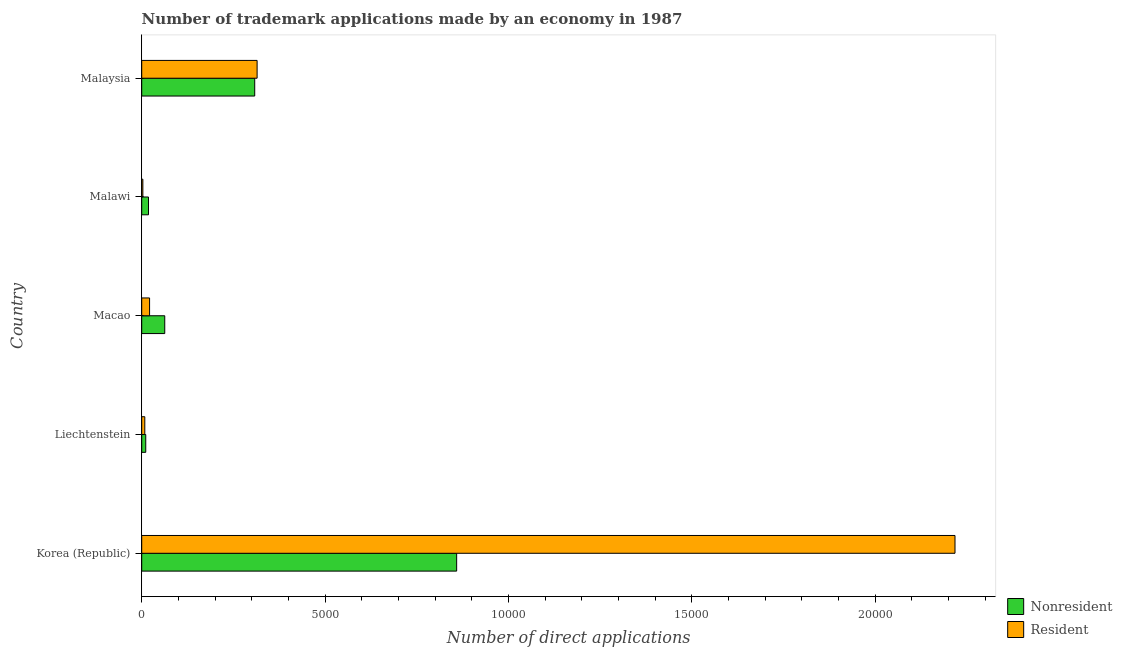How many different coloured bars are there?
Your answer should be compact. 2. How many groups of bars are there?
Your answer should be very brief. 5. Are the number of bars per tick equal to the number of legend labels?
Your answer should be very brief. Yes. Are the number of bars on each tick of the Y-axis equal?
Provide a short and direct response. Yes. What is the label of the 3rd group of bars from the top?
Keep it short and to the point. Macao. What is the number of trademark applications made by non residents in Liechtenstein?
Give a very brief answer. 110. Across all countries, what is the maximum number of trademark applications made by residents?
Provide a succinct answer. 2.22e+04. Across all countries, what is the minimum number of trademark applications made by non residents?
Your answer should be very brief. 110. In which country was the number of trademark applications made by non residents minimum?
Provide a succinct answer. Liechtenstein. What is the total number of trademark applications made by non residents in the graph?
Keep it short and to the point. 1.26e+04. What is the difference between the number of trademark applications made by non residents in Korea (Republic) and that in Liechtenstein?
Make the answer very short. 8477. What is the difference between the number of trademark applications made by non residents in Korea (Republic) and the number of trademark applications made by residents in Macao?
Your response must be concise. 8373. What is the average number of trademark applications made by residents per country?
Make the answer very short. 5130. What is the difference between the number of trademark applications made by non residents and number of trademark applications made by residents in Liechtenstein?
Your answer should be very brief. 26. In how many countries, is the number of trademark applications made by non residents greater than 21000 ?
Your answer should be very brief. 0. What is the ratio of the number of trademark applications made by residents in Korea (Republic) to that in Malaysia?
Ensure brevity in your answer.  7.05. Is the number of trademark applications made by non residents in Korea (Republic) less than that in Malawi?
Your response must be concise. No. What is the difference between the highest and the second highest number of trademark applications made by non residents?
Your answer should be compact. 5506. What is the difference between the highest and the lowest number of trademark applications made by residents?
Offer a very short reply. 2.21e+04. In how many countries, is the number of trademark applications made by residents greater than the average number of trademark applications made by residents taken over all countries?
Provide a short and direct response. 1. What does the 1st bar from the top in Malawi represents?
Offer a very short reply. Resident. What does the 2nd bar from the bottom in Macao represents?
Provide a succinct answer. Resident. Are all the bars in the graph horizontal?
Provide a short and direct response. Yes. What is the difference between two consecutive major ticks on the X-axis?
Provide a succinct answer. 5000. Are the values on the major ticks of X-axis written in scientific E-notation?
Ensure brevity in your answer.  No. Does the graph contain any zero values?
Your answer should be compact. No. How many legend labels are there?
Your response must be concise. 2. How are the legend labels stacked?
Make the answer very short. Vertical. What is the title of the graph?
Offer a terse response. Number of trademark applications made by an economy in 1987. Does "Drinking water services" appear as one of the legend labels in the graph?
Ensure brevity in your answer.  No. What is the label or title of the X-axis?
Your answer should be compact. Number of direct applications. What is the label or title of the Y-axis?
Offer a terse response. Country. What is the Number of direct applications in Nonresident in Korea (Republic)?
Offer a very short reply. 8587. What is the Number of direct applications in Resident in Korea (Republic)?
Keep it short and to the point. 2.22e+04. What is the Number of direct applications in Nonresident in Liechtenstein?
Your answer should be compact. 110. What is the Number of direct applications in Resident in Liechtenstein?
Your answer should be compact. 84. What is the Number of direct applications of Nonresident in Macao?
Offer a terse response. 628. What is the Number of direct applications of Resident in Macao?
Provide a succinct answer. 214. What is the Number of direct applications of Nonresident in Malawi?
Offer a very short reply. 185. What is the Number of direct applications of Resident in Malawi?
Your answer should be compact. 31. What is the Number of direct applications in Nonresident in Malaysia?
Your answer should be compact. 3081. What is the Number of direct applications of Resident in Malaysia?
Give a very brief answer. 3146. Across all countries, what is the maximum Number of direct applications of Nonresident?
Keep it short and to the point. 8587. Across all countries, what is the maximum Number of direct applications of Resident?
Provide a succinct answer. 2.22e+04. Across all countries, what is the minimum Number of direct applications in Nonresident?
Your answer should be compact. 110. What is the total Number of direct applications in Nonresident in the graph?
Ensure brevity in your answer.  1.26e+04. What is the total Number of direct applications in Resident in the graph?
Your response must be concise. 2.56e+04. What is the difference between the Number of direct applications of Nonresident in Korea (Republic) and that in Liechtenstein?
Offer a terse response. 8477. What is the difference between the Number of direct applications of Resident in Korea (Republic) and that in Liechtenstein?
Provide a short and direct response. 2.21e+04. What is the difference between the Number of direct applications of Nonresident in Korea (Republic) and that in Macao?
Make the answer very short. 7959. What is the difference between the Number of direct applications in Resident in Korea (Republic) and that in Macao?
Provide a succinct answer. 2.20e+04. What is the difference between the Number of direct applications in Nonresident in Korea (Republic) and that in Malawi?
Make the answer very short. 8402. What is the difference between the Number of direct applications in Resident in Korea (Republic) and that in Malawi?
Your answer should be compact. 2.21e+04. What is the difference between the Number of direct applications of Nonresident in Korea (Republic) and that in Malaysia?
Your answer should be very brief. 5506. What is the difference between the Number of direct applications of Resident in Korea (Republic) and that in Malaysia?
Give a very brief answer. 1.90e+04. What is the difference between the Number of direct applications of Nonresident in Liechtenstein and that in Macao?
Provide a short and direct response. -518. What is the difference between the Number of direct applications in Resident in Liechtenstein and that in Macao?
Give a very brief answer. -130. What is the difference between the Number of direct applications of Nonresident in Liechtenstein and that in Malawi?
Provide a short and direct response. -75. What is the difference between the Number of direct applications of Resident in Liechtenstein and that in Malawi?
Keep it short and to the point. 53. What is the difference between the Number of direct applications in Nonresident in Liechtenstein and that in Malaysia?
Keep it short and to the point. -2971. What is the difference between the Number of direct applications in Resident in Liechtenstein and that in Malaysia?
Make the answer very short. -3062. What is the difference between the Number of direct applications in Nonresident in Macao and that in Malawi?
Your answer should be very brief. 443. What is the difference between the Number of direct applications of Resident in Macao and that in Malawi?
Make the answer very short. 183. What is the difference between the Number of direct applications in Nonresident in Macao and that in Malaysia?
Provide a succinct answer. -2453. What is the difference between the Number of direct applications in Resident in Macao and that in Malaysia?
Provide a short and direct response. -2932. What is the difference between the Number of direct applications of Nonresident in Malawi and that in Malaysia?
Keep it short and to the point. -2896. What is the difference between the Number of direct applications in Resident in Malawi and that in Malaysia?
Ensure brevity in your answer.  -3115. What is the difference between the Number of direct applications in Nonresident in Korea (Republic) and the Number of direct applications in Resident in Liechtenstein?
Give a very brief answer. 8503. What is the difference between the Number of direct applications of Nonresident in Korea (Republic) and the Number of direct applications of Resident in Macao?
Keep it short and to the point. 8373. What is the difference between the Number of direct applications in Nonresident in Korea (Republic) and the Number of direct applications in Resident in Malawi?
Ensure brevity in your answer.  8556. What is the difference between the Number of direct applications in Nonresident in Korea (Republic) and the Number of direct applications in Resident in Malaysia?
Provide a short and direct response. 5441. What is the difference between the Number of direct applications in Nonresident in Liechtenstein and the Number of direct applications in Resident in Macao?
Give a very brief answer. -104. What is the difference between the Number of direct applications in Nonresident in Liechtenstein and the Number of direct applications in Resident in Malawi?
Make the answer very short. 79. What is the difference between the Number of direct applications of Nonresident in Liechtenstein and the Number of direct applications of Resident in Malaysia?
Keep it short and to the point. -3036. What is the difference between the Number of direct applications of Nonresident in Macao and the Number of direct applications of Resident in Malawi?
Provide a succinct answer. 597. What is the difference between the Number of direct applications in Nonresident in Macao and the Number of direct applications in Resident in Malaysia?
Make the answer very short. -2518. What is the difference between the Number of direct applications in Nonresident in Malawi and the Number of direct applications in Resident in Malaysia?
Your answer should be compact. -2961. What is the average Number of direct applications in Nonresident per country?
Your response must be concise. 2518.2. What is the average Number of direct applications in Resident per country?
Your answer should be very brief. 5130. What is the difference between the Number of direct applications in Nonresident and Number of direct applications in Resident in Korea (Republic)?
Ensure brevity in your answer.  -1.36e+04. What is the difference between the Number of direct applications in Nonresident and Number of direct applications in Resident in Liechtenstein?
Ensure brevity in your answer.  26. What is the difference between the Number of direct applications of Nonresident and Number of direct applications of Resident in Macao?
Make the answer very short. 414. What is the difference between the Number of direct applications in Nonresident and Number of direct applications in Resident in Malawi?
Your answer should be very brief. 154. What is the difference between the Number of direct applications in Nonresident and Number of direct applications in Resident in Malaysia?
Your response must be concise. -65. What is the ratio of the Number of direct applications of Nonresident in Korea (Republic) to that in Liechtenstein?
Offer a very short reply. 78.06. What is the ratio of the Number of direct applications in Resident in Korea (Republic) to that in Liechtenstein?
Keep it short and to the point. 263.99. What is the ratio of the Number of direct applications in Nonresident in Korea (Republic) to that in Macao?
Give a very brief answer. 13.67. What is the ratio of the Number of direct applications of Resident in Korea (Republic) to that in Macao?
Give a very brief answer. 103.62. What is the ratio of the Number of direct applications in Nonresident in Korea (Republic) to that in Malawi?
Your answer should be very brief. 46.42. What is the ratio of the Number of direct applications of Resident in Korea (Republic) to that in Malawi?
Your answer should be compact. 715.32. What is the ratio of the Number of direct applications in Nonresident in Korea (Republic) to that in Malaysia?
Give a very brief answer. 2.79. What is the ratio of the Number of direct applications of Resident in Korea (Republic) to that in Malaysia?
Provide a succinct answer. 7.05. What is the ratio of the Number of direct applications of Nonresident in Liechtenstein to that in Macao?
Your answer should be compact. 0.18. What is the ratio of the Number of direct applications of Resident in Liechtenstein to that in Macao?
Give a very brief answer. 0.39. What is the ratio of the Number of direct applications in Nonresident in Liechtenstein to that in Malawi?
Your answer should be very brief. 0.59. What is the ratio of the Number of direct applications of Resident in Liechtenstein to that in Malawi?
Offer a terse response. 2.71. What is the ratio of the Number of direct applications of Nonresident in Liechtenstein to that in Malaysia?
Offer a very short reply. 0.04. What is the ratio of the Number of direct applications in Resident in Liechtenstein to that in Malaysia?
Make the answer very short. 0.03. What is the ratio of the Number of direct applications in Nonresident in Macao to that in Malawi?
Provide a short and direct response. 3.39. What is the ratio of the Number of direct applications of Resident in Macao to that in Malawi?
Provide a succinct answer. 6.9. What is the ratio of the Number of direct applications of Nonresident in Macao to that in Malaysia?
Ensure brevity in your answer.  0.2. What is the ratio of the Number of direct applications of Resident in Macao to that in Malaysia?
Provide a succinct answer. 0.07. What is the ratio of the Number of direct applications of Resident in Malawi to that in Malaysia?
Your answer should be compact. 0.01. What is the difference between the highest and the second highest Number of direct applications in Nonresident?
Make the answer very short. 5506. What is the difference between the highest and the second highest Number of direct applications in Resident?
Keep it short and to the point. 1.90e+04. What is the difference between the highest and the lowest Number of direct applications in Nonresident?
Keep it short and to the point. 8477. What is the difference between the highest and the lowest Number of direct applications in Resident?
Provide a short and direct response. 2.21e+04. 